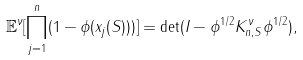<formula> <loc_0><loc_0><loc_500><loc_500>\mathbb { E } ^ { \nu } [ \prod _ { j = 1 } ^ { n } ( 1 - \phi ( x _ { j } ( S ) ) ) ] = \det ( I - \phi ^ { 1 / 2 } K _ { n , S } ^ { \nu } \phi ^ { 1 / 2 } ) ,</formula> 